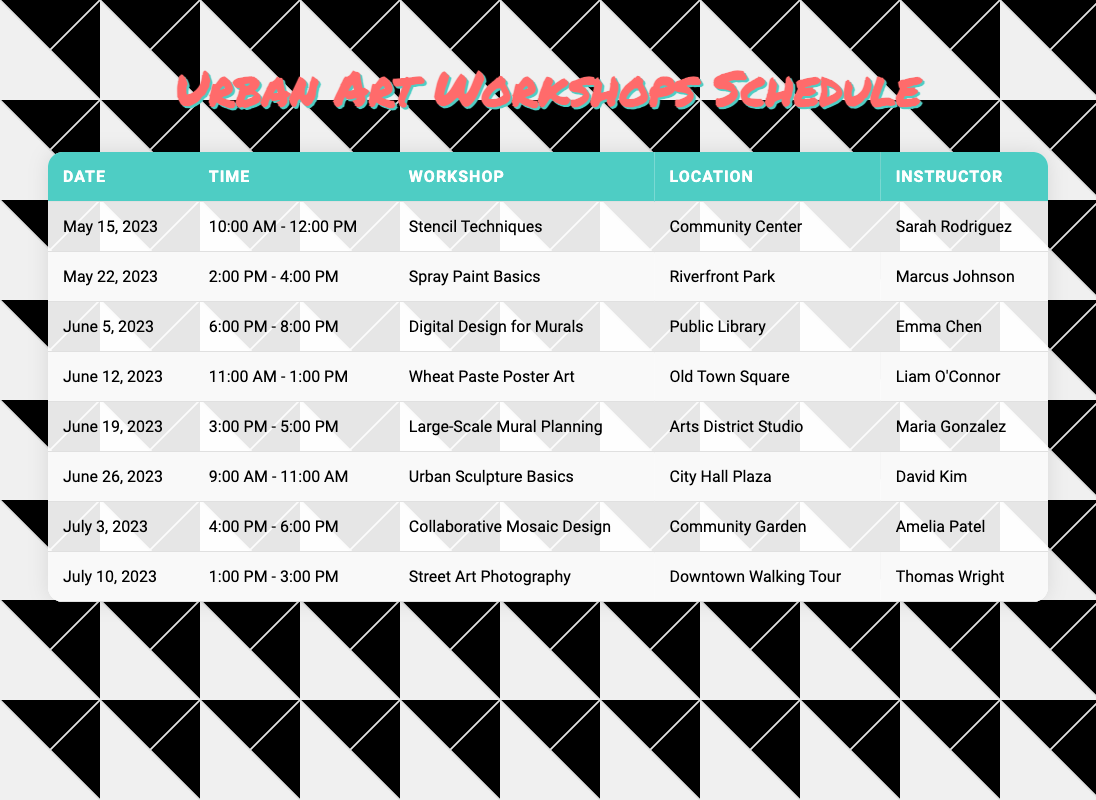What is the date for the "Digital Design for Murals" workshop? The table lists multiple workshops along with their dates. To find the date for "Digital Design for Murals," I will look through the workshop column for that name, which corresponds to June 5, 2023.
Answer: June 5, 2023 Who is the instructor for the "Spray Paint Basics" workshop? By scanning the table's rows, I find the workshop "Spray Paint Basics" listed on May 22, 2023. The corresponding instructor for this workshop is Marcus Johnson as per the table.
Answer: Marcus Johnson What locations are hosting workshops in June? The table provides several workshops in June. By filtering the rows that have dates in June, I find the locations are: Public Library, Old Town Square, Arts District Studio, and City Hall Plaza.
Answer: Public Library, Old Town Square, Arts District Studio, City Hall Plaza Are there any workshops scheduled for the Community Center? I will check the Location column for any mentions of "Community Center." The first row indicates that the "Stencil Techniques" workshop is hosted there on May 15, 2023, confirming that there is a workshop scheduled for that location.
Answer: Yes Which workshop occurs last in the schedule? To determine which workshop occurs last, I look at the date column and identify the latest date listed, which is July 10, 2023, for the "Street Art Photography" workshop. This shows that it is the last scheduled workshop.
Answer: Street Art Photography What is the average time duration for the workshops held in June? The workshops in June have the following durations: June 5, 2023 (2 hours), June 12, 2023 (2 hours), June 19, 2023 (2 hours), and June 26, 2023 (2 hours). To find the average, I sum all these durations: 2 + 2 + 2 + 2 = 8 hours. Then, dividing by the number of workshops (4) gives me an average of 8/4 = 2 hours.
Answer: 2 hours How many workshops take place in the community garden? Checking the location column for mentions of "Community Garden," I see that there is one workshop listed there, which is the "Collaborative Mosaic Design" on July 3, 2023. This confirms there is only one workshop at that location.
Answer: 1 What is the total number of hours of all workshops scheduled in June? In June, there are four workshops, each with a duration of 2 hours. So, I calculate the total hours: 2 hours x 4 workshops = 8 hours total for all June workshops.
Answer: 8 hours 